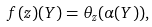<formula> <loc_0><loc_0><loc_500><loc_500>f ( z ) ( Y ) = \theta _ { z } ( \alpha ( Y ) ) ,</formula> 